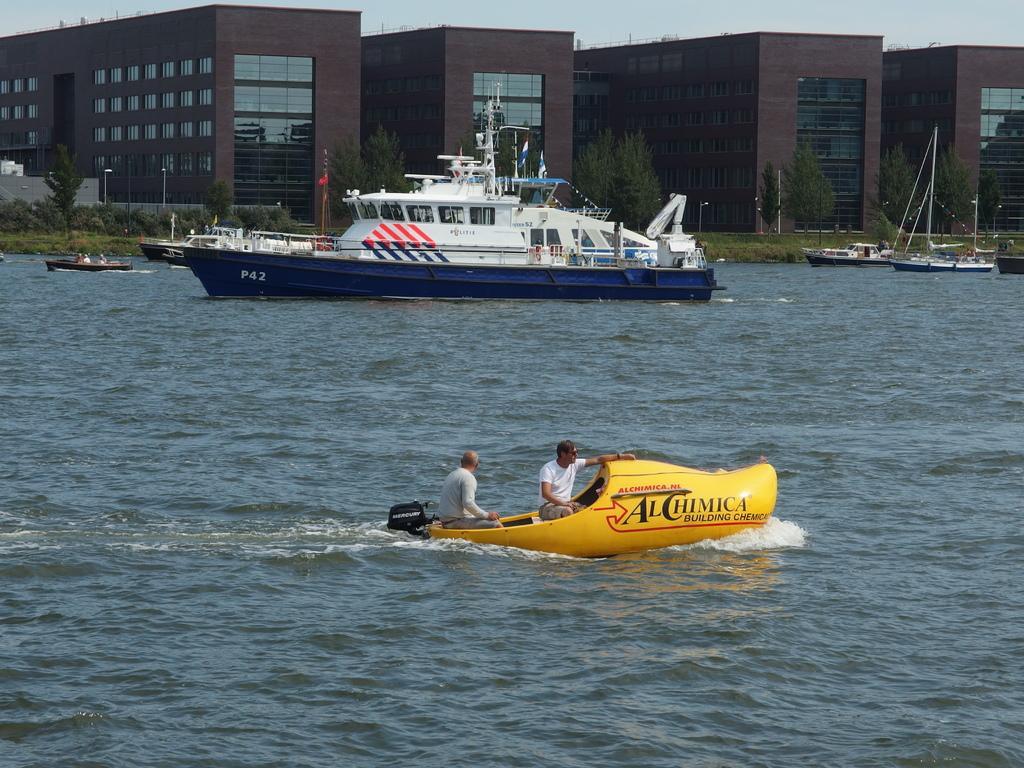Could you give a brief overview of what you see in this image? In the image we can see there are people sitting in boat and beside there is a ship. Behind there are buildings and trees. 